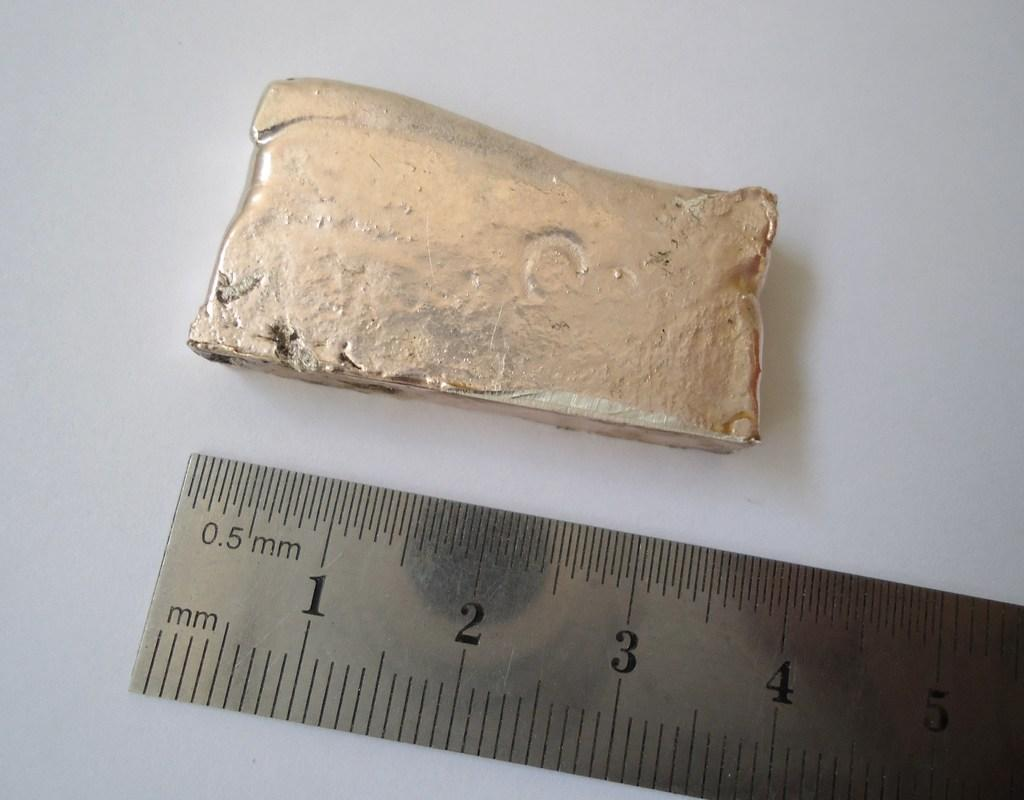<image>
Relay a brief, clear account of the picture shown. Special kind of rock that is being measured, and it is about 3.75 inches long. 